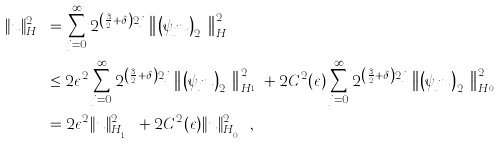<formula> <loc_0><loc_0><loc_500><loc_500>\| u \| _ { H _ { s , \delta } } ^ { 2 } & = \sum _ { j = 0 } ^ { \infty } 2 ^ { \left ( \frac { 3 } { 2 } + \delta \right ) 2 j } \left \| \left ( \psi _ { j } u \right ) _ { 2 ^ { j } } \right \| _ { H ^ { s } } ^ { 2 } \\ & \leq 2 \epsilon ^ { 2 } \sum _ { j = 0 } ^ { \infty } 2 ^ { \left ( \frac { 3 } { 2 } + \delta \right ) 2 j } \left \| \left ( \psi _ { j } u \right ) _ { 2 ^ { j } } \right \| _ { H ^ { s _ { 1 } } } ^ { 2 } + 2 C ^ { 2 } ( \epsilon ) \sum _ { j = 0 } ^ { \infty } 2 ^ { \left ( \frac { 3 } { 2 } + \delta \right ) 2 j } \left \| \left ( \psi _ { j } u \right ) _ { 2 ^ { j } } \right \| _ { H ^ { s _ { 0 } } } ^ { 2 } \\ & = 2 \epsilon ^ { 2 } \| u \| _ { H _ { s _ { 1 } , \delta } } ^ { 2 } + 2 C ^ { 2 } ( \epsilon ) \| u \| _ { H _ { s _ { 0 } , \delta } } ^ { 2 } ,</formula> 